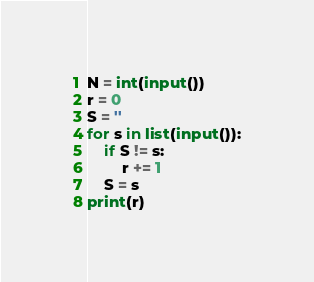<code> <loc_0><loc_0><loc_500><loc_500><_Python_>N = int(input())
r = 0
S = ''
for s in list(input()):
    if S != s:
        r += 1
    S = s
print(r)</code> 